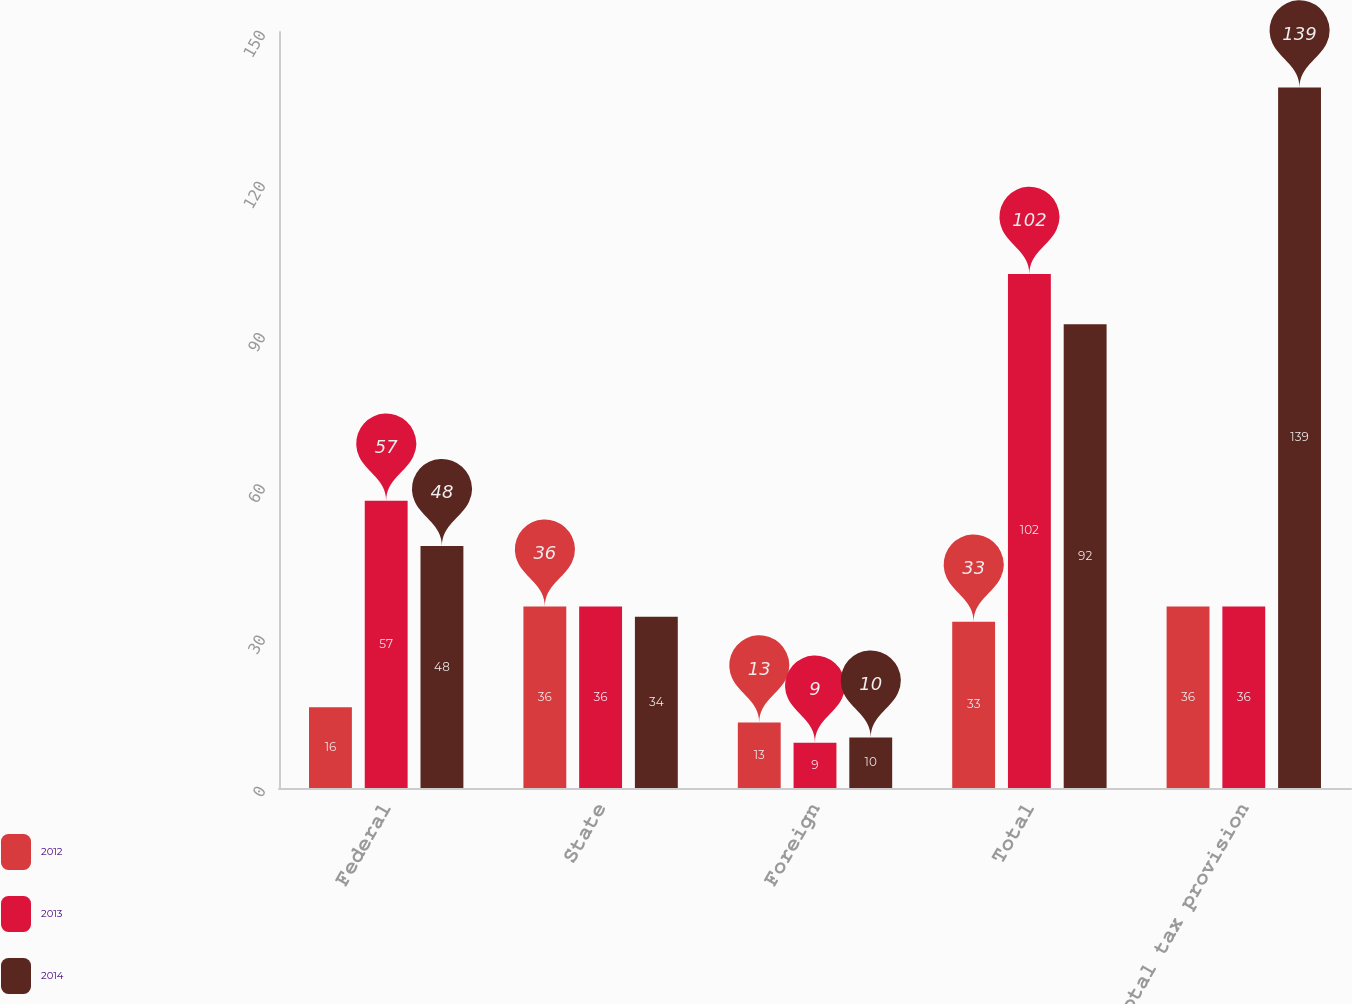Convert chart to OTSL. <chart><loc_0><loc_0><loc_500><loc_500><stacked_bar_chart><ecel><fcel>Federal<fcel>State<fcel>Foreign<fcel>Total<fcel>Total tax provision<nl><fcel>2012<fcel>16<fcel>36<fcel>13<fcel>33<fcel>36<nl><fcel>2013<fcel>57<fcel>36<fcel>9<fcel>102<fcel>36<nl><fcel>2014<fcel>48<fcel>34<fcel>10<fcel>92<fcel>139<nl></chart> 